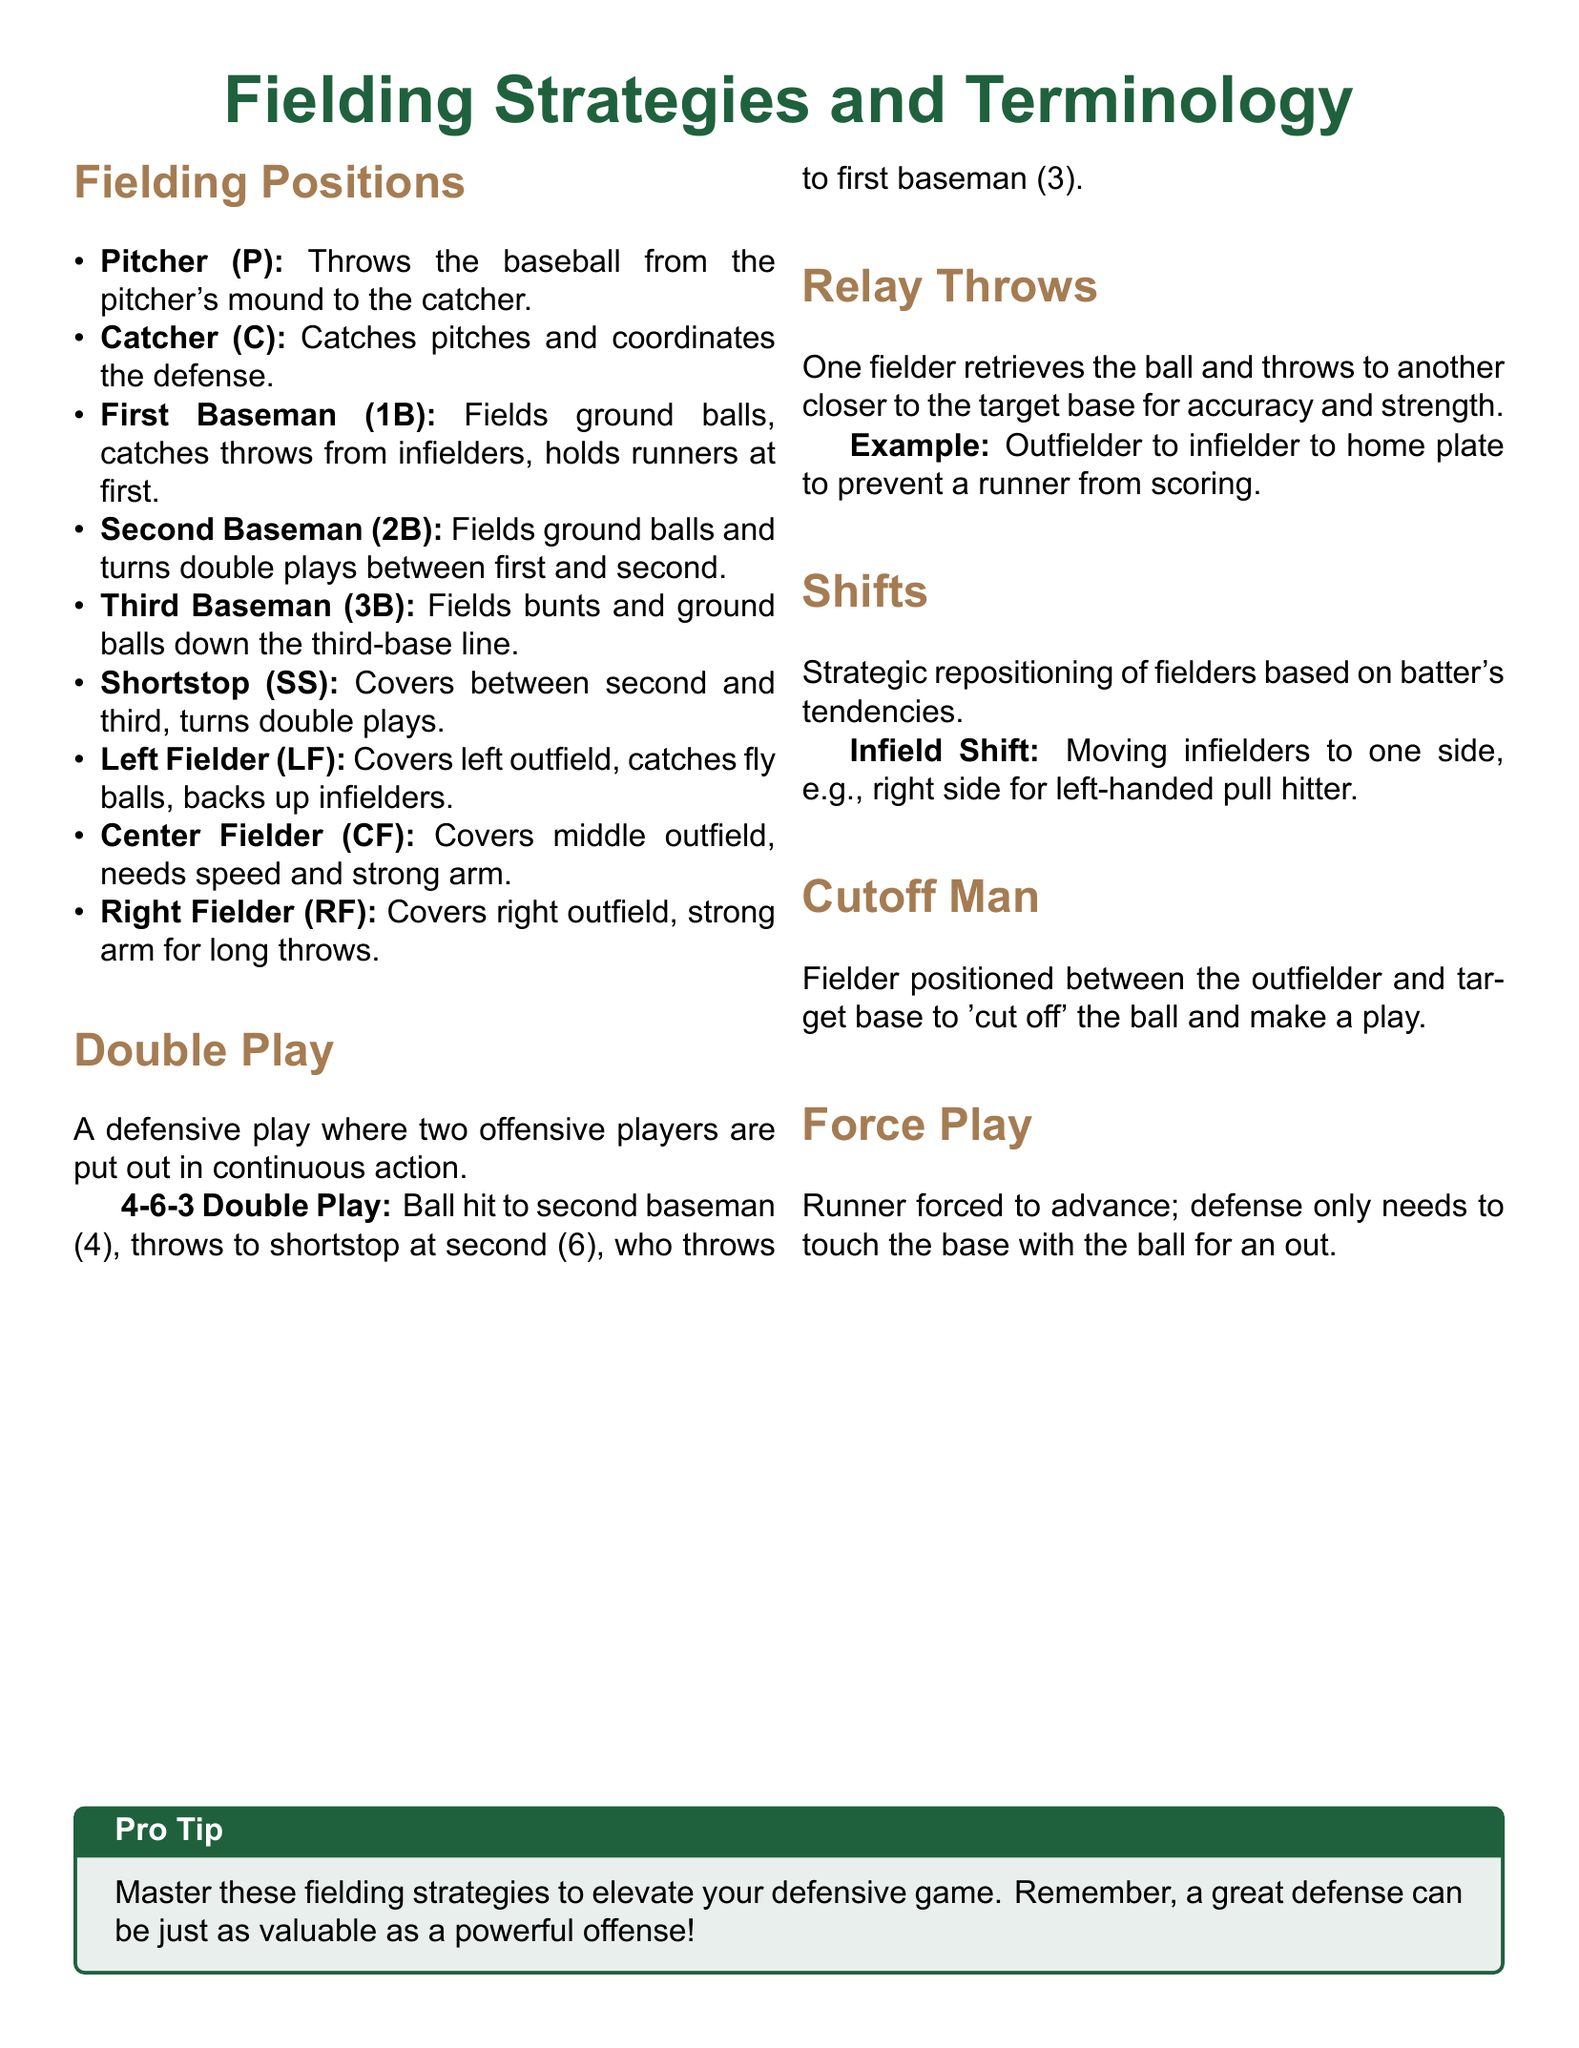What is the role of the catcher? The catcher catches pitches and coordinates the defense, as stated in the document under Fielding Positions.
Answer: Catches pitches and coordinates the defense What is a 4-6-3 double play? A 4-6-3 double play is a defensive play where the second baseman throws to the shortstop at second and then to the first baseman.
Answer: Second baseman to shortstop to first baseman What is the definition of a force play? A force play occurs when a runner is forced to advance and the defense only needs to touch the base with the ball for an out.
Answer: Touch the base with the ball What type of shift is described for left-handed pull hitters? The document describes an infield shift where infielders move to one side, specifically the right side for left-handed pull hitters.
Answer: Infield Shift What is the purpose of a cutoff man? According to the document, a cutoff man is positioned to 'cut off' the ball and make a play efficiently.
Answer: To cut off the ball 